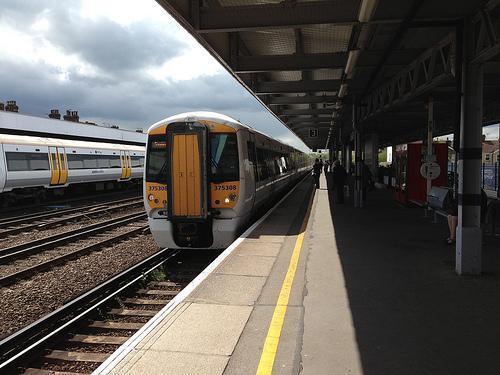How many trains are visible?
Give a very brief answer. 2. 